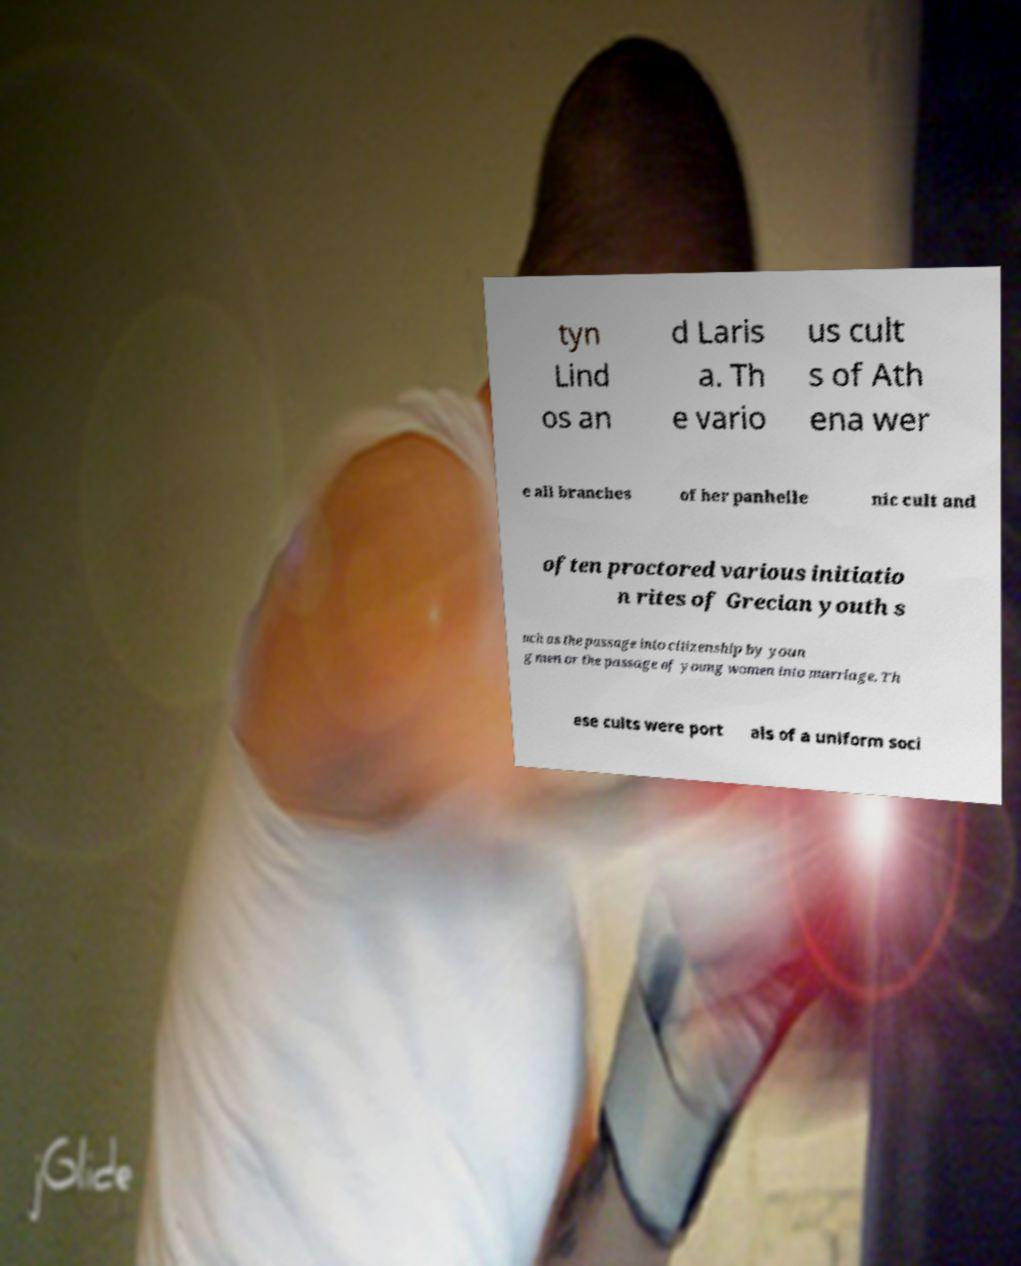Could you extract and type out the text from this image? tyn Lind os an d Laris a. Th e vario us cult s of Ath ena wer e all branches of her panhelle nic cult and often proctored various initiatio n rites of Grecian youth s uch as the passage into citizenship by youn g men or the passage of young women into marriage. Th ese cults were port als of a uniform soci 